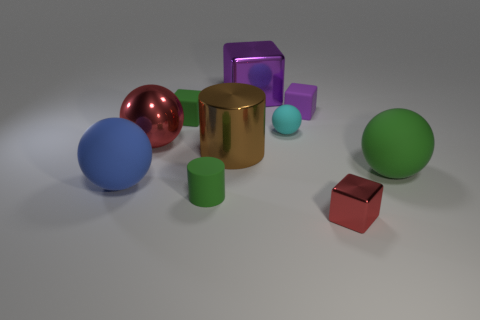Is there a green cylinder made of the same material as the large blue sphere?
Your answer should be compact. Yes. What number of objects are tiny things on the left side of the small green cylinder or cubes that are on the right side of the tiny cylinder?
Your answer should be very brief. 4. Do the shiny block right of the small matte ball and the tiny matte ball have the same color?
Your answer should be compact. No. How many other objects are the same color as the tiny rubber cylinder?
Your answer should be very brief. 2. What is the red cube made of?
Provide a short and direct response. Metal. Does the green thing to the right of the purple matte object have the same size as the small red metallic cube?
Offer a terse response. No. Is there anything else that is the same size as the red sphere?
Provide a short and direct response. Yes. The cyan rubber thing that is the same shape as the blue rubber thing is what size?
Provide a short and direct response. Small. Are there the same number of cyan objects that are behind the large metal ball and green blocks on the right side of the tiny metal cube?
Offer a terse response. No. There is a shiny thing in front of the green ball; what size is it?
Offer a very short reply. Small. 